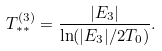<formula> <loc_0><loc_0><loc_500><loc_500>T ^ { ( 3 ) } _ { * * } = \frac { | E _ { 3 } | } { \ln ( | E _ { 3 } | / 2 T _ { 0 } ) } .</formula> 